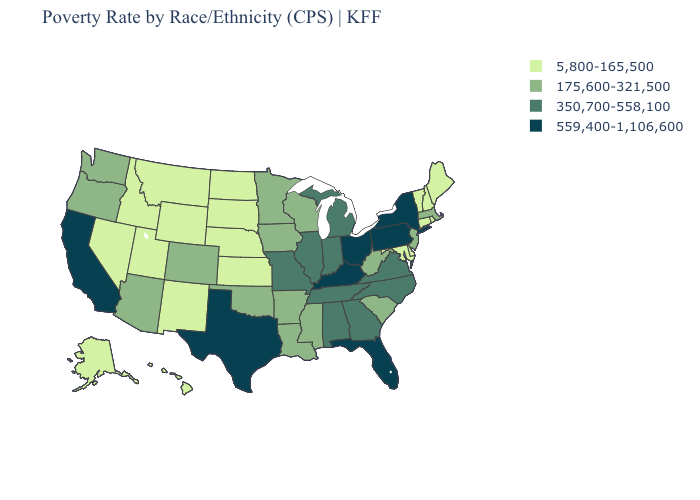Does West Virginia have the highest value in the South?
Be succinct. No. Name the states that have a value in the range 350,700-558,100?
Be succinct. Alabama, Georgia, Illinois, Indiana, Michigan, Missouri, North Carolina, Tennessee, Virginia. What is the value of Arkansas?
Quick response, please. 175,600-321,500. What is the value of Iowa?
Be succinct. 175,600-321,500. Among the states that border Idaho , does Montana have the highest value?
Give a very brief answer. No. Does Kansas have the lowest value in the USA?
Quick response, please. Yes. What is the lowest value in the MidWest?
Give a very brief answer. 5,800-165,500. Which states have the lowest value in the Northeast?
Short answer required. Connecticut, Maine, New Hampshire, Rhode Island, Vermont. What is the value of Wyoming?
Write a very short answer. 5,800-165,500. Name the states that have a value in the range 350,700-558,100?
Concise answer only. Alabama, Georgia, Illinois, Indiana, Michigan, Missouri, North Carolina, Tennessee, Virginia. Name the states that have a value in the range 350,700-558,100?
Be succinct. Alabama, Georgia, Illinois, Indiana, Michigan, Missouri, North Carolina, Tennessee, Virginia. Name the states that have a value in the range 559,400-1,106,600?
Keep it brief. California, Florida, Kentucky, New York, Ohio, Pennsylvania, Texas. Does the map have missing data?
Answer briefly. No. Name the states that have a value in the range 5,800-165,500?
Quick response, please. Alaska, Connecticut, Delaware, Hawaii, Idaho, Kansas, Maine, Maryland, Montana, Nebraska, Nevada, New Hampshire, New Mexico, North Dakota, Rhode Island, South Dakota, Utah, Vermont, Wyoming. Among the states that border Iowa , does Illinois have the highest value?
Keep it brief. Yes. 